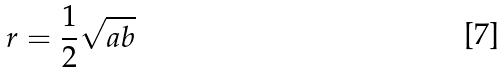Convert formula to latex. <formula><loc_0><loc_0><loc_500><loc_500>r = \frac { 1 } { 2 } \sqrt { a b }</formula> 